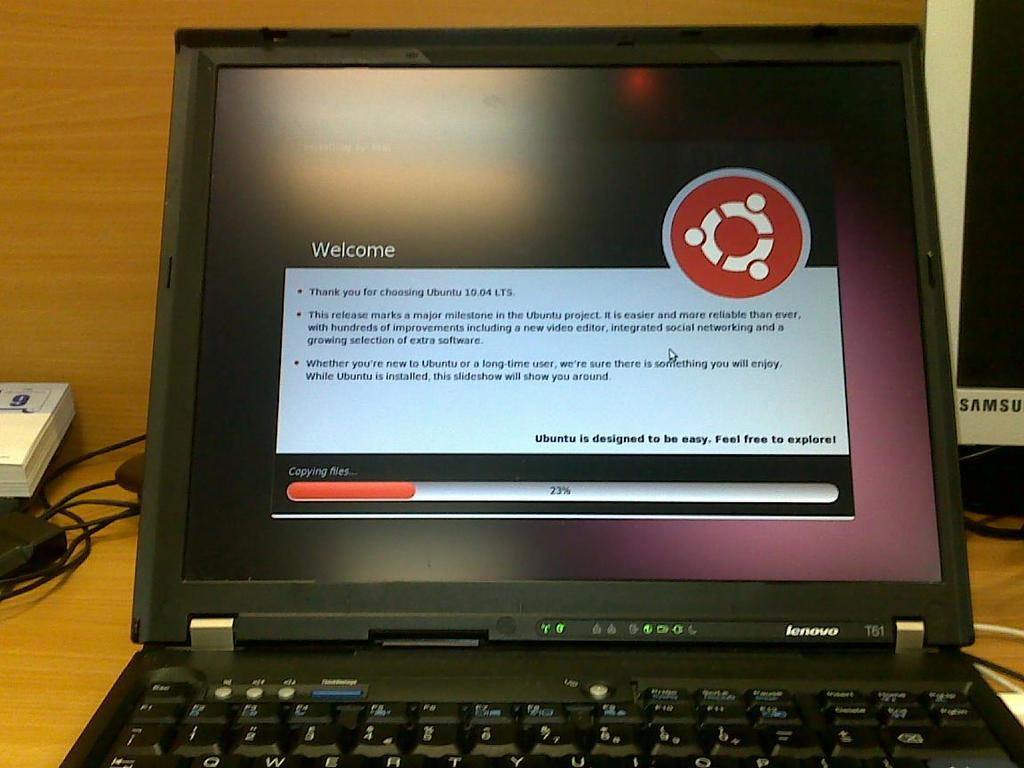<image>
Summarize the visual content of the image. The welcome screen of a laptop showing a progress bar of 23 percent 